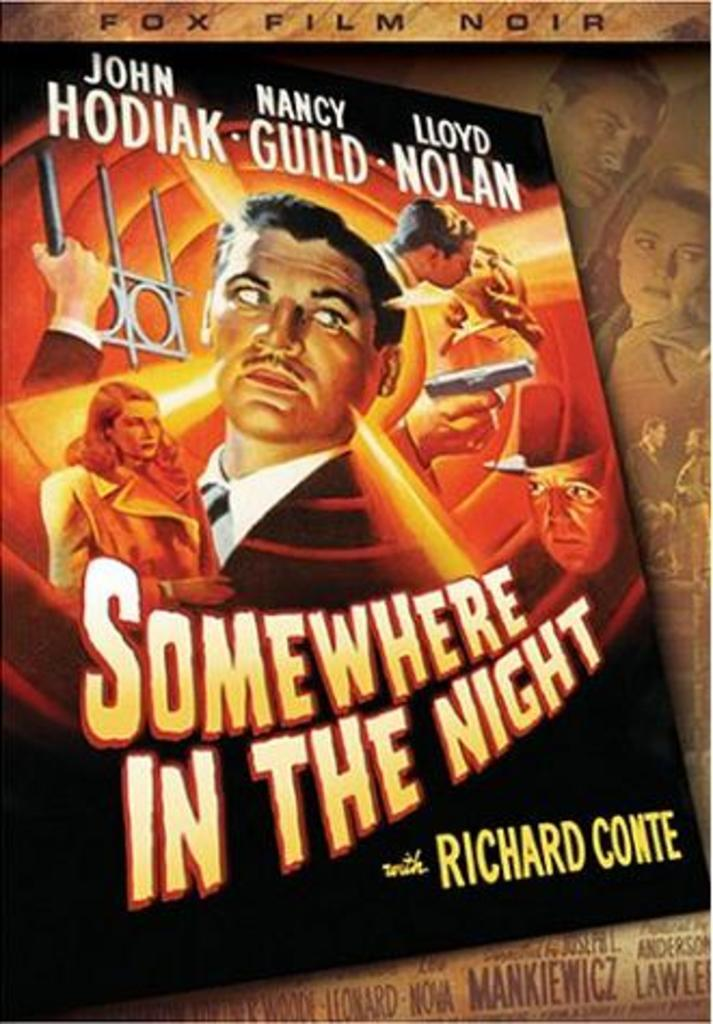Provide a one-sentence caption for the provided image. A poster with men and women on it for a movie called Somewhere In The Night. 